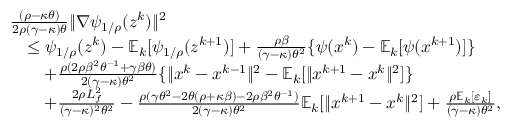Convert formula to latex. <formula><loc_0><loc_0><loc_500><loc_500>\begin{array} { r l } & { \frac { ( \rho - \kappa \theta ) } { 2 \rho ( \gamma - \kappa ) \theta } \| \nabla \psi _ { 1 / \rho } ( z ^ { k } ) \| ^ { 2 } } \\ & { \quad \leq \psi _ { 1 / \rho } ( z ^ { k } ) - \mathbb { E } _ { k } [ \psi _ { 1 / \rho } ( z ^ { k + 1 } ) ] + \frac { \rho \beta } { ( \gamma - \kappa ) \theta ^ { 2 } } \{ \psi ( x ^ { k } ) - \mathbb { E } _ { k } [ \psi ( x ^ { k + 1 } ) ] \} } \\ & { \quad + \frac { \rho ( 2 \rho \beta ^ { 2 } \theta ^ { - 1 } + \gamma \beta \theta ) } { 2 ( \gamma - \kappa ) \theta ^ { 2 } } \{ \| x ^ { k } - x ^ { k - 1 } \| ^ { 2 } - \mathbb { E } _ { k } [ \| x ^ { k + 1 } - x ^ { k } \| ^ { 2 } ] \} } \\ & { \quad + \frac { 2 \rho L _ { f } ^ { 2 } } { ( \gamma - \kappa ) ^ { 2 } \theta ^ { 2 } } - \frac { \rho ( \gamma \theta ^ { 2 } - 2 \theta ( \rho + \kappa \beta ) - 2 \rho \beta ^ { 2 } \theta ^ { - 1 } ) } { 2 ( \gamma - \kappa ) \theta ^ { 2 } } \mathbb { E } _ { k } [ \| x ^ { k + 1 } - x ^ { k } \| ^ { 2 } ] + \frac { \rho \mathbb { E } _ { k } [ \varepsilon _ { k } ] } { ( \gamma - \kappa ) \theta ^ { 2 } } , } \end{array}</formula> 